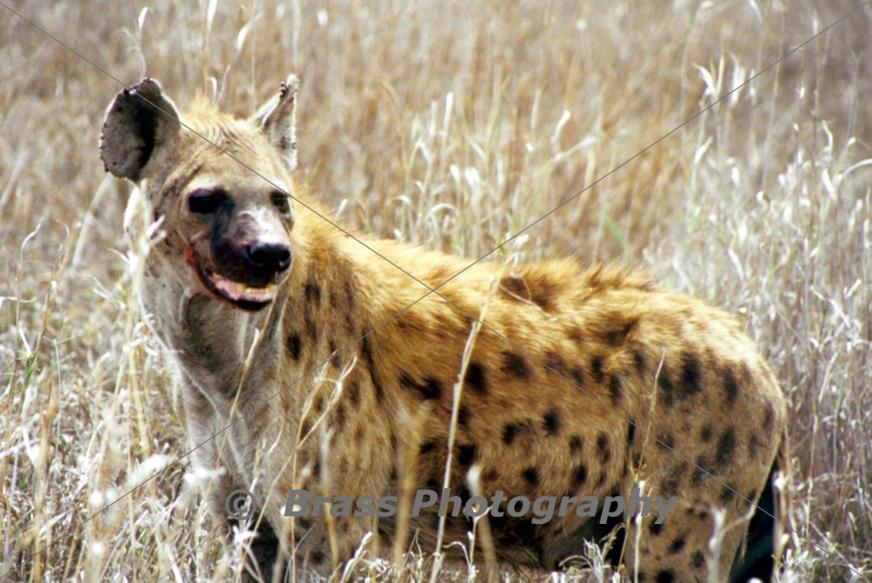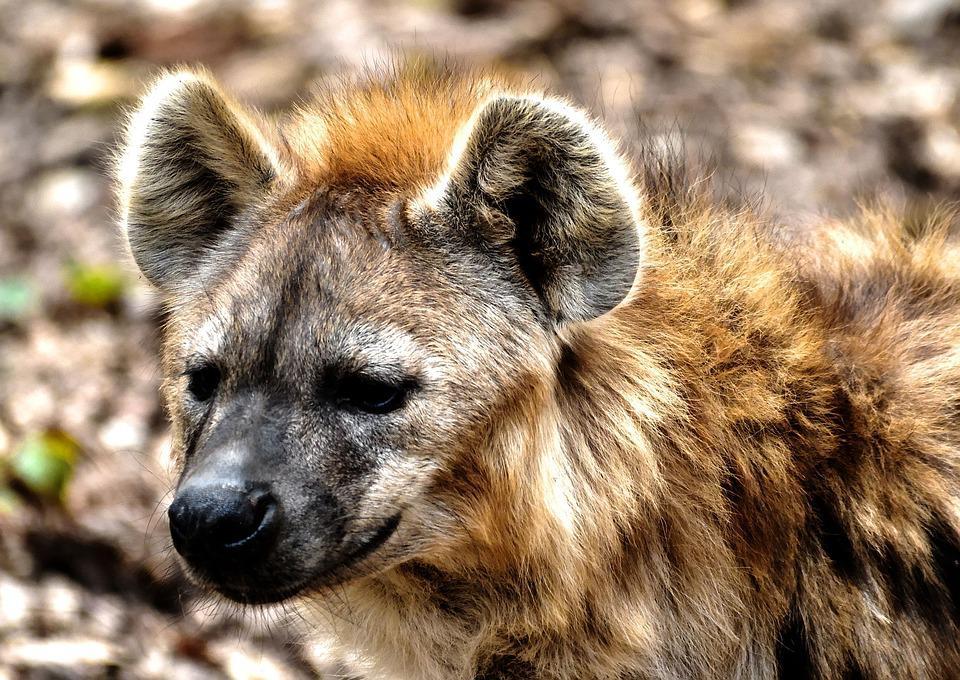The first image is the image on the left, the second image is the image on the right. Assess this claim about the two images: "Only one image shows a hyena with mouth agape showing tongue and teeth.". Correct or not? Answer yes or no. No. 